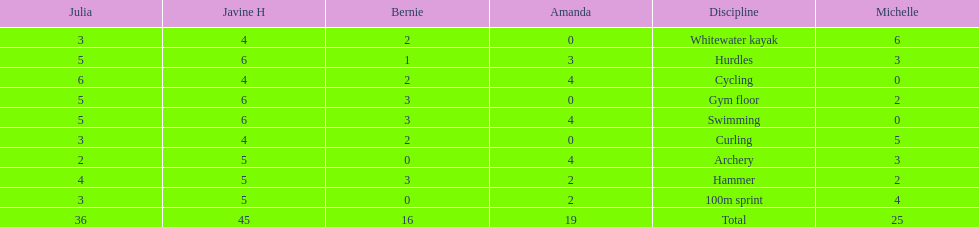Which of the girls had the least amount in archery? Bernie. 